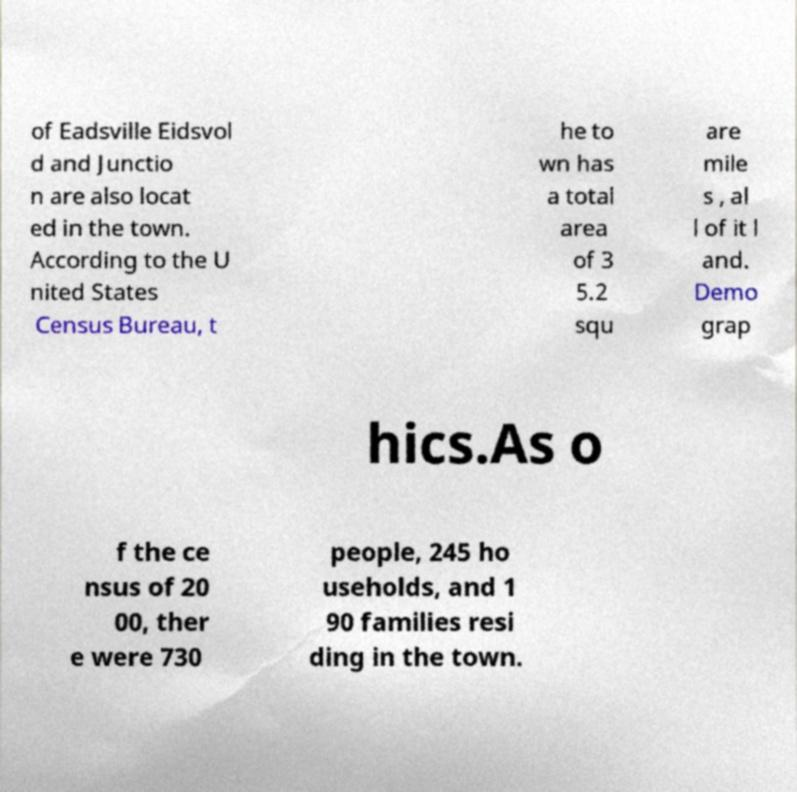What messages or text are displayed in this image? I need them in a readable, typed format. of Eadsville Eidsvol d and Junctio n are also locat ed in the town. According to the U nited States Census Bureau, t he to wn has a total area of 3 5.2 squ are mile s , al l of it l and. Demo grap hics.As o f the ce nsus of 20 00, ther e were 730 people, 245 ho useholds, and 1 90 families resi ding in the town. 